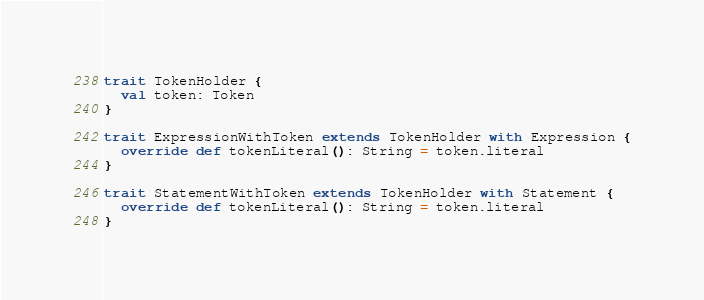Convert code to text. <code><loc_0><loc_0><loc_500><loc_500><_Scala_>
trait TokenHolder {
  val token: Token
}

trait ExpressionWithToken extends TokenHolder with Expression {
  override def tokenLiteral(): String = token.literal
}

trait StatementWithToken extends TokenHolder with Statement {
  override def tokenLiteral(): String = token.literal
}
</code> 